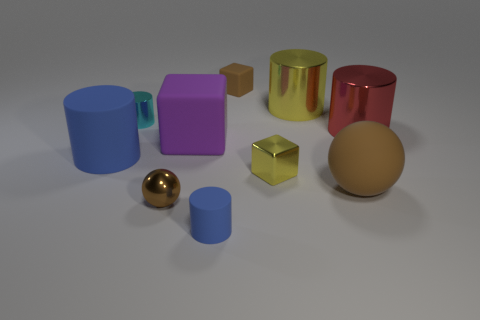Subtract all matte blocks. How many blocks are left? 1 Subtract all spheres. How many objects are left? 8 Subtract all brown blocks. How many red cylinders are left? 1 Add 5 large brown matte objects. How many large brown matte objects exist? 6 Subtract all cyan cylinders. How many cylinders are left? 4 Subtract 0 cyan cubes. How many objects are left? 10 Subtract 1 blocks. How many blocks are left? 2 Subtract all green spheres. Subtract all brown cylinders. How many spheres are left? 2 Subtract all small green metal balls. Subtract all tiny balls. How many objects are left? 9 Add 1 large rubber spheres. How many large rubber spheres are left? 2 